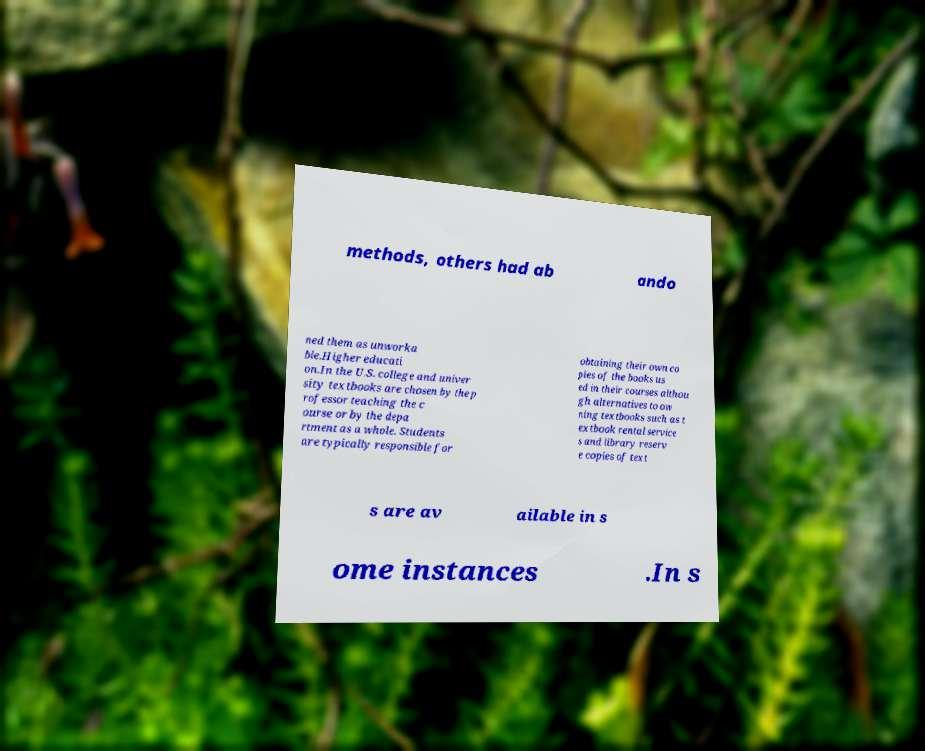Can you read and provide the text displayed in the image?This photo seems to have some interesting text. Can you extract and type it out for me? methods, others had ab ando ned them as unworka ble.Higher educati on.In the U.S. college and univer sity textbooks are chosen by the p rofessor teaching the c ourse or by the depa rtment as a whole. Students are typically responsible for obtaining their own co pies of the books us ed in their courses althou gh alternatives to ow ning textbooks such as t extbook rental service s and library reserv e copies of text s are av ailable in s ome instances .In s 